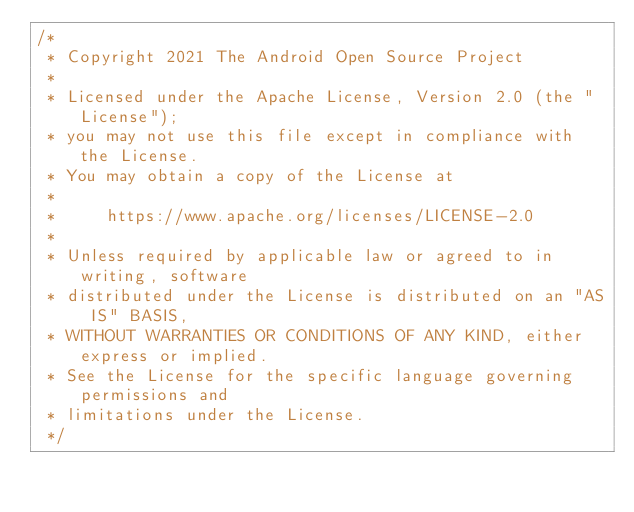Convert code to text. <code><loc_0><loc_0><loc_500><loc_500><_Kotlin_>/*
 * Copyright 2021 The Android Open Source Project
 *
 * Licensed under the Apache License, Version 2.0 (the "License");
 * you may not use this file except in compliance with the License.
 * You may obtain a copy of the License at
 *
 *     https://www.apache.org/licenses/LICENSE-2.0
 *
 * Unless required by applicable law or agreed to in writing, software
 * distributed under the License is distributed on an "AS IS" BASIS,
 * WITHOUT WARRANTIES OR CONDITIONS OF ANY KIND, either express or implied.
 * See the License for the specific language governing permissions and
 * limitations under the License.
 */</code> 